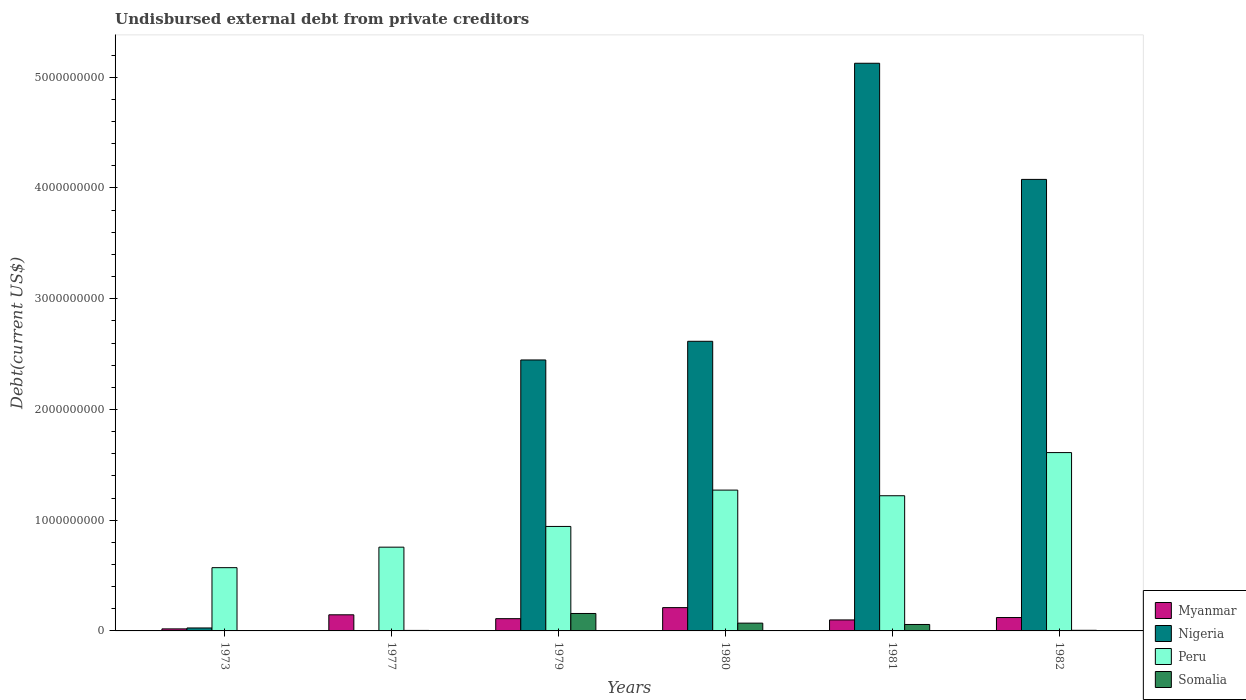How many different coloured bars are there?
Your answer should be very brief. 4. How many groups of bars are there?
Your answer should be very brief. 6. Are the number of bars per tick equal to the number of legend labels?
Your answer should be compact. Yes. How many bars are there on the 1st tick from the right?
Give a very brief answer. 4. What is the label of the 3rd group of bars from the left?
Provide a succinct answer. 1979. What is the total debt in Peru in 1977?
Offer a terse response. 7.56e+08. Across all years, what is the maximum total debt in Myanmar?
Provide a succinct answer. 2.10e+08. Across all years, what is the minimum total debt in Peru?
Offer a very short reply. 5.71e+08. In which year was the total debt in Peru minimum?
Ensure brevity in your answer.  1973. What is the total total debt in Somalia in the graph?
Provide a short and direct response. 2.97e+08. What is the difference between the total debt in Nigeria in 1980 and that in 1982?
Keep it short and to the point. -1.46e+09. What is the difference between the total debt in Somalia in 1973 and the total debt in Peru in 1980?
Give a very brief answer. -1.27e+09. What is the average total debt in Myanmar per year?
Provide a short and direct response. 1.18e+08. In the year 1973, what is the difference between the total debt in Peru and total debt in Myanmar?
Offer a terse response. 5.53e+08. In how many years, is the total debt in Somalia greater than 3000000000 US$?
Your response must be concise. 0. What is the ratio of the total debt in Nigeria in 1979 to that in 1982?
Make the answer very short. 0.6. Is the total debt in Myanmar in 1980 less than that in 1982?
Offer a very short reply. No. Is the difference between the total debt in Peru in 1977 and 1982 greater than the difference between the total debt in Myanmar in 1977 and 1982?
Offer a terse response. No. What is the difference between the highest and the second highest total debt in Myanmar?
Ensure brevity in your answer.  6.49e+07. What is the difference between the highest and the lowest total debt in Myanmar?
Give a very brief answer. 1.92e+08. What does the 1st bar from the left in 1973 represents?
Give a very brief answer. Myanmar. What does the 4th bar from the right in 1973 represents?
Provide a short and direct response. Myanmar. How many bars are there?
Your answer should be very brief. 24. Are the values on the major ticks of Y-axis written in scientific E-notation?
Make the answer very short. No. Does the graph contain any zero values?
Keep it short and to the point. No. Does the graph contain grids?
Keep it short and to the point. No. How many legend labels are there?
Make the answer very short. 4. How are the legend labels stacked?
Provide a short and direct response. Vertical. What is the title of the graph?
Keep it short and to the point. Undisbursed external debt from private creditors. Does "Senegal" appear as one of the legend labels in the graph?
Provide a succinct answer. No. What is the label or title of the X-axis?
Provide a short and direct response. Years. What is the label or title of the Y-axis?
Your answer should be very brief. Debt(current US$). What is the Debt(current US$) in Myanmar in 1973?
Your answer should be compact. 1.84e+07. What is the Debt(current US$) of Nigeria in 1973?
Your answer should be compact. 2.67e+07. What is the Debt(current US$) of Peru in 1973?
Keep it short and to the point. 5.71e+08. What is the Debt(current US$) of Somalia in 1973?
Provide a short and direct response. 1.00e+06. What is the Debt(current US$) of Myanmar in 1977?
Keep it short and to the point. 1.46e+08. What is the Debt(current US$) in Nigeria in 1977?
Your answer should be compact. 2.79e+06. What is the Debt(current US$) in Peru in 1977?
Make the answer very short. 7.56e+08. What is the Debt(current US$) in Somalia in 1977?
Offer a terse response. 4.53e+06. What is the Debt(current US$) of Myanmar in 1979?
Keep it short and to the point. 1.11e+08. What is the Debt(current US$) in Nigeria in 1979?
Ensure brevity in your answer.  2.45e+09. What is the Debt(current US$) of Peru in 1979?
Offer a terse response. 9.44e+08. What is the Debt(current US$) in Somalia in 1979?
Offer a terse response. 1.58e+08. What is the Debt(current US$) of Myanmar in 1980?
Ensure brevity in your answer.  2.10e+08. What is the Debt(current US$) in Nigeria in 1980?
Your answer should be very brief. 2.62e+09. What is the Debt(current US$) in Peru in 1980?
Ensure brevity in your answer.  1.27e+09. What is the Debt(current US$) in Somalia in 1980?
Offer a terse response. 7.03e+07. What is the Debt(current US$) in Myanmar in 1981?
Ensure brevity in your answer.  9.93e+07. What is the Debt(current US$) in Nigeria in 1981?
Provide a succinct answer. 5.13e+09. What is the Debt(current US$) of Peru in 1981?
Give a very brief answer. 1.22e+09. What is the Debt(current US$) in Somalia in 1981?
Give a very brief answer. 5.82e+07. What is the Debt(current US$) in Myanmar in 1982?
Provide a short and direct response. 1.21e+08. What is the Debt(current US$) of Nigeria in 1982?
Ensure brevity in your answer.  4.08e+09. What is the Debt(current US$) of Peru in 1982?
Provide a succinct answer. 1.61e+09. What is the Debt(current US$) of Somalia in 1982?
Offer a very short reply. 5.57e+06. Across all years, what is the maximum Debt(current US$) of Myanmar?
Ensure brevity in your answer.  2.10e+08. Across all years, what is the maximum Debt(current US$) of Nigeria?
Your response must be concise. 5.13e+09. Across all years, what is the maximum Debt(current US$) in Peru?
Give a very brief answer. 1.61e+09. Across all years, what is the maximum Debt(current US$) of Somalia?
Provide a short and direct response. 1.58e+08. Across all years, what is the minimum Debt(current US$) in Myanmar?
Your answer should be compact. 1.84e+07. Across all years, what is the minimum Debt(current US$) in Nigeria?
Give a very brief answer. 2.79e+06. Across all years, what is the minimum Debt(current US$) in Peru?
Provide a succinct answer. 5.71e+08. What is the total Debt(current US$) of Myanmar in the graph?
Your answer should be very brief. 7.05e+08. What is the total Debt(current US$) of Nigeria in the graph?
Your response must be concise. 1.43e+1. What is the total Debt(current US$) in Peru in the graph?
Make the answer very short. 6.37e+09. What is the total Debt(current US$) of Somalia in the graph?
Provide a short and direct response. 2.97e+08. What is the difference between the Debt(current US$) of Myanmar in 1973 and that in 1977?
Keep it short and to the point. -1.27e+08. What is the difference between the Debt(current US$) of Nigeria in 1973 and that in 1977?
Give a very brief answer. 2.39e+07. What is the difference between the Debt(current US$) in Peru in 1973 and that in 1977?
Provide a short and direct response. -1.85e+08. What is the difference between the Debt(current US$) of Somalia in 1973 and that in 1977?
Ensure brevity in your answer.  -3.53e+06. What is the difference between the Debt(current US$) of Myanmar in 1973 and that in 1979?
Provide a succinct answer. -9.24e+07. What is the difference between the Debt(current US$) in Nigeria in 1973 and that in 1979?
Your answer should be very brief. -2.42e+09. What is the difference between the Debt(current US$) of Peru in 1973 and that in 1979?
Your answer should be compact. -3.72e+08. What is the difference between the Debt(current US$) of Somalia in 1973 and that in 1979?
Your answer should be compact. -1.57e+08. What is the difference between the Debt(current US$) of Myanmar in 1973 and that in 1980?
Keep it short and to the point. -1.92e+08. What is the difference between the Debt(current US$) of Nigeria in 1973 and that in 1980?
Your answer should be very brief. -2.59e+09. What is the difference between the Debt(current US$) in Peru in 1973 and that in 1980?
Your answer should be very brief. -7.00e+08. What is the difference between the Debt(current US$) in Somalia in 1973 and that in 1980?
Your response must be concise. -6.93e+07. What is the difference between the Debt(current US$) in Myanmar in 1973 and that in 1981?
Provide a succinct answer. -8.10e+07. What is the difference between the Debt(current US$) in Nigeria in 1973 and that in 1981?
Make the answer very short. -5.10e+09. What is the difference between the Debt(current US$) in Peru in 1973 and that in 1981?
Your answer should be compact. -6.49e+08. What is the difference between the Debt(current US$) in Somalia in 1973 and that in 1981?
Your answer should be compact. -5.72e+07. What is the difference between the Debt(current US$) of Myanmar in 1973 and that in 1982?
Offer a terse response. -1.03e+08. What is the difference between the Debt(current US$) in Nigeria in 1973 and that in 1982?
Provide a succinct answer. -4.05e+09. What is the difference between the Debt(current US$) in Peru in 1973 and that in 1982?
Provide a short and direct response. -1.04e+09. What is the difference between the Debt(current US$) of Somalia in 1973 and that in 1982?
Offer a terse response. -4.57e+06. What is the difference between the Debt(current US$) of Myanmar in 1977 and that in 1979?
Provide a short and direct response. 3.48e+07. What is the difference between the Debt(current US$) of Nigeria in 1977 and that in 1979?
Offer a very short reply. -2.44e+09. What is the difference between the Debt(current US$) of Peru in 1977 and that in 1979?
Offer a very short reply. -1.87e+08. What is the difference between the Debt(current US$) of Somalia in 1977 and that in 1979?
Give a very brief answer. -1.53e+08. What is the difference between the Debt(current US$) in Myanmar in 1977 and that in 1980?
Keep it short and to the point. -6.49e+07. What is the difference between the Debt(current US$) in Nigeria in 1977 and that in 1980?
Your response must be concise. -2.61e+09. What is the difference between the Debt(current US$) in Peru in 1977 and that in 1980?
Ensure brevity in your answer.  -5.15e+08. What is the difference between the Debt(current US$) in Somalia in 1977 and that in 1980?
Keep it short and to the point. -6.58e+07. What is the difference between the Debt(current US$) of Myanmar in 1977 and that in 1981?
Make the answer very short. 4.62e+07. What is the difference between the Debt(current US$) in Nigeria in 1977 and that in 1981?
Your answer should be compact. -5.12e+09. What is the difference between the Debt(current US$) of Peru in 1977 and that in 1981?
Provide a short and direct response. -4.64e+08. What is the difference between the Debt(current US$) of Somalia in 1977 and that in 1981?
Your answer should be compact. -5.37e+07. What is the difference between the Debt(current US$) in Myanmar in 1977 and that in 1982?
Offer a terse response. 2.47e+07. What is the difference between the Debt(current US$) of Nigeria in 1977 and that in 1982?
Ensure brevity in your answer.  -4.07e+09. What is the difference between the Debt(current US$) in Peru in 1977 and that in 1982?
Your answer should be compact. -8.54e+08. What is the difference between the Debt(current US$) of Somalia in 1977 and that in 1982?
Your answer should be very brief. -1.04e+06. What is the difference between the Debt(current US$) in Myanmar in 1979 and that in 1980?
Your answer should be compact. -9.97e+07. What is the difference between the Debt(current US$) of Nigeria in 1979 and that in 1980?
Give a very brief answer. -1.69e+08. What is the difference between the Debt(current US$) of Peru in 1979 and that in 1980?
Offer a terse response. -3.28e+08. What is the difference between the Debt(current US$) in Somalia in 1979 and that in 1980?
Give a very brief answer. 8.73e+07. What is the difference between the Debt(current US$) in Myanmar in 1979 and that in 1981?
Offer a very short reply. 1.14e+07. What is the difference between the Debt(current US$) of Nigeria in 1979 and that in 1981?
Keep it short and to the point. -2.68e+09. What is the difference between the Debt(current US$) in Peru in 1979 and that in 1981?
Offer a terse response. -2.77e+08. What is the difference between the Debt(current US$) in Somalia in 1979 and that in 1981?
Provide a succinct answer. 9.94e+07. What is the difference between the Debt(current US$) of Myanmar in 1979 and that in 1982?
Make the answer very short. -1.01e+07. What is the difference between the Debt(current US$) in Nigeria in 1979 and that in 1982?
Your answer should be very brief. -1.63e+09. What is the difference between the Debt(current US$) of Peru in 1979 and that in 1982?
Make the answer very short. -6.67e+08. What is the difference between the Debt(current US$) in Somalia in 1979 and that in 1982?
Your answer should be compact. 1.52e+08. What is the difference between the Debt(current US$) in Myanmar in 1980 and that in 1981?
Your response must be concise. 1.11e+08. What is the difference between the Debt(current US$) in Nigeria in 1980 and that in 1981?
Make the answer very short. -2.51e+09. What is the difference between the Debt(current US$) of Peru in 1980 and that in 1981?
Provide a succinct answer. 5.10e+07. What is the difference between the Debt(current US$) in Somalia in 1980 and that in 1981?
Provide a succinct answer. 1.21e+07. What is the difference between the Debt(current US$) in Myanmar in 1980 and that in 1982?
Your response must be concise. 8.96e+07. What is the difference between the Debt(current US$) in Nigeria in 1980 and that in 1982?
Keep it short and to the point. -1.46e+09. What is the difference between the Debt(current US$) of Peru in 1980 and that in 1982?
Make the answer very short. -3.39e+08. What is the difference between the Debt(current US$) in Somalia in 1980 and that in 1982?
Make the answer very short. 6.48e+07. What is the difference between the Debt(current US$) in Myanmar in 1981 and that in 1982?
Your response must be concise. -2.15e+07. What is the difference between the Debt(current US$) in Nigeria in 1981 and that in 1982?
Ensure brevity in your answer.  1.05e+09. What is the difference between the Debt(current US$) of Peru in 1981 and that in 1982?
Your answer should be compact. -3.90e+08. What is the difference between the Debt(current US$) of Somalia in 1981 and that in 1982?
Provide a short and direct response. 5.26e+07. What is the difference between the Debt(current US$) in Myanmar in 1973 and the Debt(current US$) in Nigeria in 1977?
Offer a terse response. 1.56e+07. What is the difference between the Debt(current US$) in Myanmar in 1973 and the Debt(current US$) in Peru in 1977?
Give a very brief answer. -7.38e+08. What is the difference between the Debt(current US$) of Myanmar in 1973 and the Debt(current US$) of Somalia in 1977?
Provide a short and direct response. 1.38e+07. What is the difference between the Debt(current US$) of Nigeria in 1973 and the Debt(current US$) of Peru in 1977?
Your answer should be compact. -7.30e+08. What is the difference between the Debt(current US$) in Nigeria in 1973 and the Debt(current US$) in Somalia in 1977?
Offer a terse response. 2.22e+07. What is the difference between the Debt(current US$) of Peru in 1973 and the Debt(current US$) of Somalia in 1977?
Keep it short and to the point. 5.67e+08. What is the difference between the Debt(current US$) in Myanmar in 1973 and the Debt(current US$) in Nigeria in 1979?
Your answer should be compact. -2.43e+09. What is the difference between the Debt(current US$) in Myanmar in 1973 and the Debt(current US$) in Peru in 1979?
Offer a terse response. -9.25e+08. What is the difference between the Debt(current US$) of Myanmar in 1973 and the Debt(current US$) of Somalia in 1979?
Your answer should be very brief. -1.39e+08. What is the difference between the Debt(current US$) of Nigeria in 1973 and the Debt(current US$) of Peru in 1979?
Ensure brevity in your answer.  -9.17e+08. What is the difference between the Debt(current US$) in Nigeria in 1973 and the Debt(current US$) in Somalia in 1979?
Your answer should be compact. -1.31e+08. What is the difference between the Debt(current US$) in Peru in 1973 and the Debt(current US$) in Somalia in 1979?
Offer a very short reply. 4.14e+08. What is the difference between the Debt(current US$) of Myanmar in 1973 and the Debt(current US$) of Nigeria in 1980?
Provide a succinct answer. -2.60e+09. What is the difference between the Debt(current US$) in Myanmar in 1973 and the Debt(current US$) in Peru in 1980?
Offer a very short reply. -1.25e+09. What is the difference between the Debt(current US$) of Myanmar in 1973 and the Debt(current US$) of Somalia in 1980?
Provide a short and direct response. -5.20e+07. What is the difference between the Debt(current US$) of Nigeria in 1973 and the Debt(current US$) of Peru in 1980?
Offer a terse response. -1.25e+09. What is the difference between the Debt(current US$) of Nigeria in 1973 and the Debt(current US$) of Somalia in 1980?
Give a very brief answer. -4.36e+07. What is the difference between the Debt(current US$) of Peru in 1973 and the Debt(current US$) of Somalia in 1980?
Your answer should be compact. 5.01e+08. What is the difference between the Debt(current US$) of Myanmar in 1973 and the Debt(current US$) of Nigeria in 1981?
Your response must be concise. -5.11e+09. What is the difference between the Debt(current US$) of Myanmar in 1973 and the Debt(current US$) of Peru in 1981?
Keep it short and to the point. -1.20e+09. What is the difference between the Debt(current US$) in Myanmar in 1973 and the Debt(current US$) in Somalia in 1981?
Provide a short and direct response. -3.98e+07. What is the difference between the Debt(current US$) of Nigeria in 1973 and the Debt(current US$) of Peru in 1981?
Offer a very short reply. -1.19e+09. What is the difference between the Debt(current US$) in Nigeria in 1973 and the Debt(current US$) in Somalia in 1981?
Offer a very short reply. -3.15e+07. What is the difference between the Debt(current US$) in Peru in 1973 and the Debt(current US$) in Somalia in 1981?
Your answer should be very brief. 5.13e+08. What is the difference between the Debt(current US$) in Myanmar in 1973 and the Debt(current US$) in Nigeria in 1982?
Your response must be concise. -4.06e+09. What is the difference between the Debt(current US$) in Myanmar in 1973 and the Debt(current US$) in Peru in 1982?
Make the answer very short. -1.59e+09. What is the difference between the Debt(current US$) in Myanmar in 1973 and the Debt(current US$) in Somalia in 1982?
Keep it short and to the point. 1.28e+07. What is the difference between the Debt(current US$) in Nigeria in 1973 and the Debt(current US$) in Peru in 1982?
Your answer should be compact. -1.58e+09. What is the difference between the Debt(current US$) in Nigeria in 1973 and the Debt(current US$) in Somalia in 1982?
Offer a very short reply. 2.11e+07. What is the difference between the Debt(current US$) of Peru in 1973 and the Debt(current US$) of Somalia in 1982?
Provide a succinct answer. 5.66e+08. What is the difference between the Debt(current US$) in Myanmar in 1977 and the Debt(current US$) in Nigeria in 1979?
Offer a terse response. -2.30e+09. What is the difference between the Debt(current US$) in Myanmar in 1977 and the Debt(current US$) in Peru in 1979?
Ensure brevity in your answer.  -7.98e+08. What is the difference between the Debt(current US$) of Myanmar in 1977 and the Debt(current US$) of Somalia in 1979?
Give a very brief answer. -1.20e+07. What is the difference between the Debt(current US$) of Nigeria in 1977 and the Debt(current US$) of Peru in 1979?
Your answer should be compact. -9.41e+08. What is the difference between the Debt(current US$) of Nigeria in 1977 and the Debt(current US$) of Somalia in 1979?
Ensure brevity in your answer.  -1.55e+08. What is the difference between the Debt(current US$) in Peru in 1977 and the Debt(current US$) in Somalia in 1979?
Give a very brief answer. 5.99e+08. What is the difference between the Debt(current US$) in Myanmar in 1977 and the Debt(current US$) in Nigeria in 1980?
Offer a terse response. -2.47e+09. What is the difference between the Debt(current US$) in Myanmar in 1977 and the Debt(current US$) in Peru in 1980?
Offer a very short reply. -1.13e+09. What is the difference between the Debt(current US$) of Myanmar in 1977 and the Debt(current US$) of Somalia in 1980?
Provide a short and direct response. 7.52e+07. What is the difference between the Debt(current US$) in Nigeria in 1977 and the Debt(current US$) in Peru in 1980?
Your answer should be compact. -1.27e+09. What is the difference between the Debt(current US$) in Nigeria in 1977 and the Debt(current US$) in Somalia in 1980?
Offer a terse response. -6.75e+07. What is the difference between the Debt(current US$) of Peru in 1977 and the Debt(current US$) of Somalia in 1980?
Ensure brevity in your answer.  6.86e+08. What is the difference between the Debt(current US$) of Myanmar in 1977 and the Debt(current US$) of Nigeria in 1981?
Give a very brief answer. -4.98e+09. What is the difference between the Debt(current US$) in Myanmar in 1977 and the Debt(current US$) in Peru in 1981?
Ensure brevity in your answer.  -1.08e+09. What is the difference between the Debt(current US$) of Myanmar in 1977 and the Debt(current US$) of Somalia in 1981?
Your response must be concise. 8.74e+07. What is the difference between the Debt(current US$) in Nigeria in 1977 and the Debt(current US$) in Peru in 1981?
Keep it short and to the point. -1.22e+09. What is the difference between the Debt(current US$) of Nigeria in 1977 and the Debt(current US$) of Somalia in 1981?
Your answer should be compact. -5.54e+07. What is the difference between the Debt(current US$) of Peru in 1977 and the Debt(current US$) of Somalia in 1981?
Offer a terse response. 6.98e+08. What is the difference between the Debt(current US$) of Myanmar in 1977 and the Debt(current US$) of Nigeria in 1982?
Give a very brief answer. -3.93e+09. What is the difference between the Debt(current US$) in Myanmar in 1977 and the Debt(current US$) in Peru in 1982?
Offer a terse response. -1.46e+09. What is the difference between the Debt(current US$) in Myanmar in 1977 and the Debt(current US$) in Somalia in 1982?
Provide a succinct answer. 1.40e+08. What is the difference between the Debt(current US$) in Nigeria in 1977 and the Debt(current US$) in Peru in 1982?
Ensure brevity in your answer.  -1.61e+09. What is the difference between the Debt(current US$) of Nigeria in 1977 and the Debt(current US$) of Somalia in 1982?
Offer a terse response. -2.78e+06. What is the difference between the Debt(current US$) in Peru in 1977 and the Debt(current US$) in Somalia in 1982?
Offer a terse response. 7.51e+08. What is the difference between the Debt(current US$) in Myanmar in 1979 and the Debt(current US$) in Nigeria in 1980?
Provide a succinct answer. -2.50e+09. What is the difference between the Debt(current US$) in Myanmar in 1979 and the Debt(current US$) in Peru in 1980?
Your response must be concise. -1.16e+09. What is the difference between the Debt(current US$) in Myanmar in 1979 and the Debt(current US$) in Somalia in 1980?
Make the answer very short. 4.04e+07. What is the difference between the Debt(current US$) of Nigeria in 1979 and the Debt(current US$) of Peru in 1980?
Ensure brevity in your answer.  1.18e+09. What is the difference between the Debt(current US$) of Nigeria in 1979 and the Debt(current US$) of Somalia in 1980?
Your response must be concise. 2.38e+09. What is the difference between the Debt(current US$) in Peru in 1979 and the Debt(current US$) in Somalia in 1980?
Your answer should be compact. 8.73e+08. What is the difference between the Debt(current US$) of Myanmar in 1979 and the Debt(current US$) of Nigeria in 1981?
Ensure brevity in your answer.  -5.02e+09. What is the difference between the Debt(current US$) of Myanmar in 1979 and the Debt(current US$) of Peru in 1981?
Offer a very short reply. -1.11e+09. What is the difference between the Debt(current US$) of Myanmar in 1979 and the Debt(current US$) of Somalia in 1981?
Your response must be concise. 5.26e+07. What is the difference between the Debt(current US$) of Nigeria in 1979 and the Debt(current US$) of Peru in 1981?
Give a very brief answer. 1.23e+09. What is the difference between the Debt(current US$) of Nigeria in 1979 and the Debt(current US$) of Somalia in 1981?
Your answer should be compact. 2.39e+09. What is the difference between the Debt(current US$) in Peru in 1979 and the Debt(current US$) in Somalia in 1981?
Provide a short and direct response. 8.85e+08. What is the difference between the Debt(current US$) in Myanmar in 1979 and the Debt(current US$) in Nigeria in 1982?
Keep it short and to the point. -3.97e+09. What is the difference between the Debt(current US$) in Myanmar in 1979 and the Debt(current US$) in Peru in 1982?
Keep it short and to the point. -1.50e+09. What is the difference between the Debt(current US$) in Myanmar in 1979 and the Debt(current US$) in Somalia in 1982?
Offer a very short reply. 1.05e+08. What is the difference between the Debt(current US$) in Nigeria in 1979 and the Debt(current US$) in Peru in 1982?
Provide a short and direct response. 8.37e+08. What is the difference between the Debt(current US$) of Nigeria in 1979 and the Debt(current US$) of Somalia in 1982?
Offer a terse response. 2.44e+09. What is the difference between the Debt(current US$) of Peru in 1979 and the Debt(current US$) of Somalia in 1982?
Ensure brevity in your answer.  9.38e+08. What is the difference between the Debt(current US$) in Myanmar in 1980 and the Debt(current US$) in Nigeria in 1981?
Ensure brevity in your answer.  -4.92e+09. What is the difference between the Debt(current US$) in Myanmar in 1980 and the Debt(current US$) in Peru in 1981?
Provide a short and direct response. -1.01e+09. What is the difference between the Debt(current US$) in Myanmar in 1980 and the Debt(current US$) in Somalia in 1981?
Your response must be concise. 1.52e+08. What is the difference between the Debt(current US$) in Nigeria in 1980 and the Debt(current US$) in Peru in 1981?
Your response must be concise. 1.39e+09. What is the difference between the Debt(current US$) of Nigeria in 1980 and the Debt(current US$) of Somalia in 1981?
Offer a very short reply. 2.56e+09. What is the difference between the Debt(current US$) in Peru in 1980 and the Debt(current US$) in Somalia in 1981?
Provide a succinct answer. 1.21e+09. What is the difference between the Debt(current US$) in Myanmar in 1980 and the Debt(current US$) in Nigeria in 1982?
Offer a terse response. -3.87e+09. What is the difference between the Debt(current US$) of Myanmar in 1980 and the Debt(current US$) of Peru in 1982?
Offer a very short reply. -1.40e+09. What is the difference between the Debt(current US$) of Myanmar in 1980 and the Debt(current US$) of Somalia in 1982?
Provide a short and direct response. 2.05e+08. What is the difference between the Debt(current US$) of Nigeria in 1980 and the Debt(current US$) of Peru in 1982?
Your response must be concise. 1.01e+09. What is the difference between the Debt(current US$) in Nigeria in 1980 and the Debt(current US$) in Somalia in 1982?
Provide a short and direct response. 2.61e+09. What is the difference between the Debt(current US$) of Peru in 1980 and the Debt(current US$) of Somalia in 1982?
Keep it short and to the point. 1.27e+09. What is the difference between the Debt(current US$) of Myanmar in 1981 and the Debt(current US$) of Nigeria in 1982?
Offer a terse response. -3.98e+09. What is the difference between the Debt(current US$) of Myanmar in 1981 and the Debt(current US$) of Peru in 1982?
Provide a succinct answer. -1.51e+09. What is the difference between the Debt(current US$) of Myanmar in 1981 and the Debt(current US$) of Somalia in 1982?
Offer a terse response. 9.38e+07. What is the difference between the Debt(current US$) of Nigeria in 1981 and the Debt(current US$) of Peru in 1982?
Your answer should be compact. 3.52e+09. What is the difference between the Debt(current US$) of Nigeria in 1981 and the Debt(current US$) of Somalia in 1982?
Offer a very short reply. 5.12e+09. What is the difference between the Debt(current US$) of Peru in 1981 and the Debt(current US$) of Somalia in 1982?
Provide a succinct answer. 1.22e+09. What is the average Debt(current US$) in Myanmar per year?
Provide a succinct answer. 1.18e+08. What is the average Debt(current US$) in Nigeria per year?
Provide a short and direct response. 2.38e+09. What is the average Debt(current US$) in Peru per year?
Give a very brief answer. 1.06e+09. What is the average Debt(current US$) of Somalia per year?
Your answer should be compact. 4.95e+07. In the year 1973, what is the difference between the Debt(current US$) of Myanmar and Debt(current US$) of Nigeria?
Make the answer very short. -8.34e+06. In the year 1973, what is the difference between the Debt(current US$) in Myanmar and Debt(current US$) in Peru?
Give a very brief answer. -5.53e+08. In the year 1973, what is the difference between the Debt(current US$) of Myanmar and Debt(current US$) of Somalia?
Your response must be concise. 1.74e+07. In the year 1973, what is the difference between the Debt(current US$) in Nigeria and Debt(current US$) in Peru?
Ensure brevity in your answer.  -5.45e+08. In the year 1973, what is the difference between the Debt(current US$) in Nigeria and Debt(current US$) in Somalia?
Ensure brevity in your answer.  2.57e+07. In the year 1973, what is the difference between the Debt(current US$) of Peru and Debt(current US$) of Somalia?
Your response must be concise. 5.70e+08. In the year 1977, what is the difference between the Debt(current US$) of Myanmar and Debt(current US$) of Nigeria?
Keep it short and to the point. 1.43e+08. In the year 1977, what is the difference between the Debt(current US$) of Myanmar and Debt(current US$) of Peru?
Your answer should be very brief. -6.11e+08. In the year 1977, what is the difference between the Debt(current US$) of Myanmar and Debt(current US$) of Somalia?
Provide a short and direct response. 1.41e+08. In the year 1977, what is the difference between the Debt(current US$) in Nigeria and Debt(current US$) in Peru?
Make the answer very short. -7.54e+08. In the year 1977, what is the difference between the Debt(current US$) in Nigeria and Debt(current US$) in Somalia?
Give a very brief answer. -1.74e+06. In the year 1977, what is the difference between the Debt(current US$) of Peru and Debt(current US$) of Somalia?
Offer a terse response. 7.52e+08. In the year 1979, what is the difference between the Debt(current US$) in Myanmar and Debt(current US$) in Nigeria?
Your answer should be very brief. -2.34e+09. In the year 1979, what is the difference between the Debt(current US$) in Myanmar and Debt(current US$) in Peru?
Ensure brevity in your answer.  -8.33e+08. In the year 1979, what is the difference between the Debt(current US$) in Myanmar and Debt(current US$) in Somalia?
Provide a succinct answer. -4.68e+07. In the year 1979, what is the difference between the Debt(current US$) of Nigeria and Debt(current US$) of Peru?
Ensure brevity in your answer.  1.50e+09. In the year 1979, what is the difference between the Debt(current US$) of Nigeria and Debt(current US$) of Somalia?
Provide a short and direct response. 2.29e+09. In the year 1979, what is the difference between the Debt(current US$) in Peru and Debt(current US$) in Somalia?
Provide a succinct answer. 7.86e+08. In the year 1980, what is the difference between the Debt(current US$) in Myanmar and Debt(current US$) in Nigeria?
Make the answer very short. -2.41e+09. In the year 1980, what is the difference between the Debt(current US$) in Myanmar and Debt(current US$) in Peru?
Your answer should be very brief. -1.06e+09. In the year 1980, what is the difference between the Debt(current US$) in Myanmar and Debt(current US$) in Somalia?
Provide a succinct answer. 1.40e+08. In the year 1980, what is the difference between the Debt(current US$) of Nigeria and Debt(current US$) of Peru?
Offer a terse response. 1.34e+09. In the year 1980, what is the difference between the Debt(current US$) of Nigeria and Debt(current US$) of Somalia?
Offer a very short reply. 2.55e+09. In the year 1980, what is the difference between the Debt(current US$) of Peru and Debt(current US$) of Somalia?
Make the answer very short. 1.20e+09. In the year 1981, what is the difference between the Debt(current US$) in Myanmar and Debt(current US$) in Nigeria?
Provide a succinct answer. -5.03e+09. In the year 1981, what is the difference between the Debt(current US$) in Myanmar and Debt(current US$) in Peru?
Provide a short and direct response. -1.12e+09. In the year 1981, what is the difference between the Debt(current US$) of Myanmar and Debt(current US$) of Somalia?
Your answer should be compact. 4.11e+07. In the year 1981, what is the difference between the Debt(current US$) in Nigeria and Debt(current US$) in Peru?
Give a very brief answer. 3.91e+09. In the year 1981, what is the difference between the Debt(current US$) of Nigeria and Debt(current US$) of Somalia?
Make the answer very short. 5.07e+09. In the year 1981, what is the difference between the Debt(current US$) in Peru and Debt(current US$) in Somalia?
Provide a succinct answer. 1.16e+09. In the year 1982, what is the difference between the Debt(current US$) of Myanmar and Debt(current US$) of Nigeria?
Your answer should be very brief. -3.96e+09. In the year 1982, what is the difference between the Debt(current US$) of Myanmar and Debt(current US$) of Peru?
Your answer should be very brief. -1.49e+09. In the year 1982, what is the difference between the Debt(current US$) of Myanmar and Debt(current US$) of Somalia?
Your answer should be very brief. 1.15e+08. In the year 1982, what is the difference between the Debt(current US$) of Nigeria and Debt(current US$) of Peru?
Your answer should be compact. 2.47e+09. In the year 1982, what is the difference between the Debt(current US$) of Nigeria and Debt(current US$) of Somalia?
Offer a very short reply. 4.07e+09. In the year 1982, what is the difference between the Debt(current US$) of Peru and Debt(current US$) of Somalia?
Give a very brief answer. 1.60e+09. What is the ratio of the Debt(current US$) in Myanmar in 1973 to that in 1977?
Offer a very short reply. 0.13. What is the ratio of the Debt(current US$) of Nigeria in 1973 to that in 1977?
Provide a short and direct response. 9.58. What is the ratio of the Debt(current US$) of Peru in 1973 to that in 1977?
Make the answer very short. 0.76. What is the ratio of the Debt(current US$) in Somalia in 1973 to that in 1977?
Keep it short and to the point. 0.22. What is the ratio of the Debt(current US$) in Myanmar in 1973 to that in 1979?
Ensure brevity in your answer.  0.17. What is the ratio of the Debt(current US$) in Nigeria in 1973 to that in 1979?
Give a very brief answer. 0.01. What is the ratio of the Debt(current US$) in Peru in 1973 to that in 1979?
Offer a terse response. 0.61. What is the ratio of the Debt(current US$) in Somalia in 1973 to that in 1979?
Provide a succinct answer. 0.01. What is the ratio of the Debt(current US$) in Myanmar in 1973 to that in 1980?
Ensure brevity in your answer.  0.09. What is the ratio of the Debt(current US$) of Nigeria in 1973 to that in 1980?
Provide a short and direct response. 0.01. What is the ratio of the Debt(current US$) in Peru in 1973 to that in 1980?
Give a very brief answer. 0.45. What is the ratio of the Debt(current US$) in Somalia in 1973 to that in 1980?
Your response must be concise. 0.01. What is the ratio of the Debt(current US$) of Myanmar in 1973 to that in 1981?
Give a very brief answer. 0.18. What is the ratio of the Debt(current US$) of Nigeria in 1973 to that in 1981?
Keep it short and to the point. 0.01. What is the ratio of the Debt(current US$) in Peru in 1973 to that in 1981?
Offer a terse response. 0.47. What is the ratio of the Debt(current US$) in Somalia in 1973 to that in 1981?
Make the answer very short. 0.02. What is the ratio of the Debt(current US$) in Myanmar in 1973 to that in 1982?
Your answer should be compact. 0.15. What is the ratio of the Debt(current US$) in Nigeria in 1973 to that in 1982?
Keep it short and to the point. 0.01. What is the ratio of the Debt(current US$) in Peru in 1973 to that in 1982?
Give a very brief answer. 0.35. What is the ratio of the Debt(current US$) of Somalia in 1973 to that in 1982?
Keep it short and to the point. 0.18. What is the ratio of the Debt(current US$) in Myanmar in 1977 to that in 1979?
Make the answer very short. 1.31. What is the ratio of the Debt(current US$) in Nigeria in 1977 to that in 1979?
Ensure brevity in your answer.  0. What is the ratio of the Debt(current US$) of Peru in 1977 to that in 1979?
Provide a succinct answer. 0.8. What is the ratio of the Debt(current US$) of Somalia in 1977 to that in 1979?
Give a very brief answer. 0.03. What is the ratio of the Debt(current US$) of Myanmar in 1977 to that in 1980?
Provide a short and direct response. 0.69. What is the ratio of the Debt(current US$) in Nigeria in 1977 to that in 1980?
Ensure brevity in your answer.  0. What is the ratio of the Debt(current US$) of Peru in 1977 to that in 1980?
Keep it short and to the point. 0.59. What is the ratio of the Debt(current US$) of Somalia in 1977 to that in 1980?
Your response must be concise. 0.06. What is the ratio of the Debt(current US$) of Myanmar in 1977 to that in 1981?
Offer a very short reply. 1.47. What is the ratio of the Debt(current US$) of Peru in 1977 to that in 1981?
Provide a short and direct response. 0.62. What is the ratio of the Debt(current US$) of Somalia in 1977 to that in 1981?
Keep it short and to the point. 0.08. What is the ratio of the Debt(current US$) in Myanmar in 1977 to that in 1982?
Offer a very short reply. 1.2. What is the ratio of the Debt(current US$) in Nigeria in 1977 to that in 1982?
Provide a short and direct response. 0. What is the ratio of the Debt(current US$) in Peru in 1977 to that in 1982?
Give a very brief answer. 0.47. What is the ratio of the Debt(current US$) in Somalia in 1977 to that in 1982?
Offer a very short reply. 0.81. What is the ratio of the Debt(current US$) in Myanmar in 1979 to that in 1980?
Your response must be concise. 0.53. What is the ratio of the Debt(current US$) in Nigeria in 1979 to that in 1980?
Provide a short and direct response. 0.94. What is the ratio of the Debt(current US$) in Peru in 1979 to that in 1980?
Provide a short and direct response. 0.74. What is the ratio of the Debt(current US$) in Somalia in 1979 to that in 1980?
Provide a succinct answer. 2.24. What is the ratio of the Debt(current US$) of Myanmar in 1979 to that in 1981?
Your response must be concise. 1.11. What is the ratio of the Debt(current US$) of Nigeria in 1979 to that in 1981?
Provide a short and direct response. 0.48. What is the ratio of the Debt(current US$) of Peru in 1979 to that in 1981?
Provide a succinct answer. 0.77. What is the ratio of the Debt(current US$) of Somalia in 1979 to that in 1981?
Your answer should be compact. 2.71. What is the ratio of the Debt(current US$) of Myanmar in 1979 to that in 1982?
Offer a terse response. 0.92. What is the ratio of the Debt(current US$) in Nigeria in 1979 to that in 1982?
Offer a very short reply. 0.6. What is the ratio of the Debt(current US$) in Peru in 1979 to that in 1982?
Ensure brevity in your answer.  0.59. What is the ratio of the Debt(current US$) of Somalia in 1979 to that in 1982?
Make the answer very short. 28.31. What is the ratio of the Debt(current US$) of Myanmar in 1980 to that in 1981?
Your response must be concise. 2.12. What is the ratio of the Debt(current US$) in Nigeria in 1980 to that in 1981?
Give a very brief answer. 0.51. What is the ratio of the Debt(current US$) of Peru in 1980 to that in 1981?
Your answer should be very brief. 1.04. What is the ratio of the Debt(current US$) in Somalia in 1980 to that in 1981?
Ensure brevity in your answer.  1.21. What is the ratio of the Debt(current US$) in Myanmar in 1980 to that in 1982?
Keep it short and to the point. 1.74. What is the ratio of the Debt(current US$) in Nigeria in 1980 to that in 1982?
Your answer should be very brief. 0.64. What is the ratio of the Debt(current US$) of Peru in 1980 to that in 1982?
Your answer should be very brief. 0.79. What is the ratio of the Debt(current US$) in Somalia in 1980 to that in 1982?
Provide a short and direct response. 12.63. What is the ratio of the Debt(current US$) in Myanmar in 1981 to that in 1982?
Offer a very short reply. 0.82. What is the ratio of the Debt(current US$) in Nigeria in 1981 to that in 1982?
Provide a short and direct response. 1.26. What is the ratio of the Debt(current US$) of Peru in 1981 to that in 1982?
Offer a very short reply. 0.76. What is the ratio of the Debt(current US$) in Somalia in 1981 to that in 1982?
Your answer should be compact. 10.45. What is the difference between the highest and the second highest Debt(current US$) in Myanmar?
Provide a succinct answer. 6.49e+07. What is the difference between the highest and the second highest Debt(current US$) of Nigeria?
Give a very brief answer. 1.05e+09. What is the difference between the highest and the second highest Debt(current US$) of Peru?
Your response must be concise. 3.39e+08. What is the difference between the highest and the second highest Debt(current US$) of Somalia?
Give a very brief answer. 8.73e+07. What is the difference between the highest and the lowest Debt(current US$) of Myanmar?
Make the answer very short. 1.92e+08. What is the difference between the highest and the lowest Debt(current US$) of Nigeria?
Your answer should be compact. 5.12e+09. What is the difference between the highest and the lowest Debt(current US$) of Peru?
Make the answer very short. 1.04e+09. What is the difference between the highest and the lowest Debt(current US$) in Somalia?
Make the answer very short. 1.57e+08. 